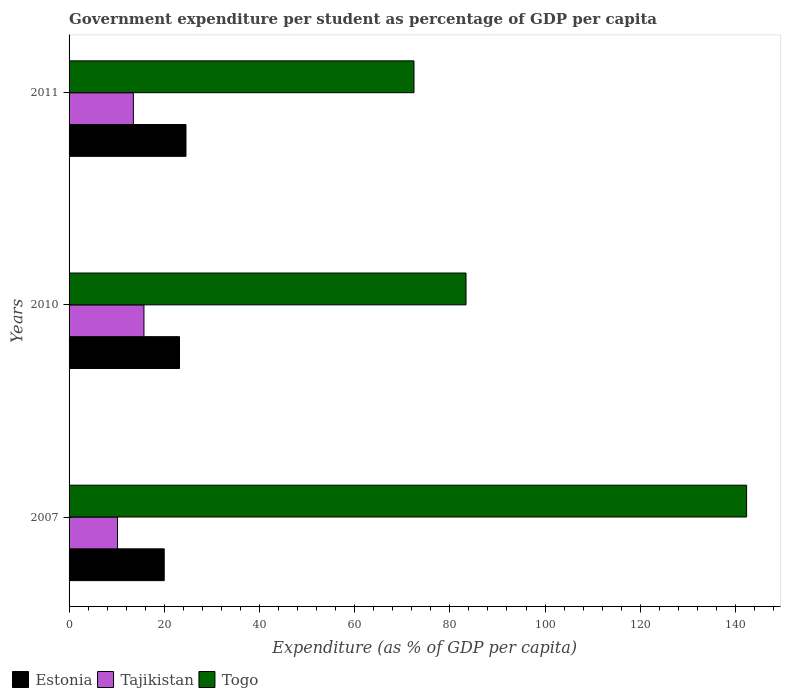How many different coloured bars are there?
Make the answer very short. 3. How many groups of bars are there?
Your answer should be compact. 3. Are the number of bars on each tick of the Y-axis equal?
Offer a very short reply. Yes. How many bars are there on the 1st tick from the bottom?
Make the answer very short. 3. What is the label of the 3rd group of bars from the top?
Keep it short and to the point. 2007. In how many cases, is the number of bars for a given year not equal to the number of legend labels?
Provide a succinct answer. 0. What is the percentage of expenditure per student in Tajikistan in 2007?
Provide a short and direct response. 10.18. Across all years, what is the maximum percentage of expenditure per student in Tajikistan?
Ensure brevity in your answer.  15.73. Across all years, what is the minimum percentage of expenditure per student in Tajikistan?
Keep it short and to the point. 10.18. In which year was the percentage of expenditure per student in Tajikistan minimum?
Ensure brevity in your answer.  2007. What is the total percentage of expenditure per student in Estonia in the graph?
Ensure brevity in your answer.  67.76. What is the difference between the percentage of expenditure per student in Togo in 2010 and that in 2011?
Keep it short and to the point. 10.93. What is the difference between the percentage of expenditure per student in Togo in 2010 and the percentage of expenditure per student in Estonia in 2011?
Your answer should be compact. 58.83. What is the average percentage of expenditure per student in Estonia per year?
Provide a succinct answer. 22.59. In the year 2010, what is the difference between the percentage of expenditure per student in Togo and percentage of expenditure per student in Estonia?
Your answer should be very brief. 60.19. In how many years, is the percentage of expenditure per student in Togo greater than 88 %?
Your response must be concise. 1. What is the ratio of the percentage of expenditure per student in Tajikistan in 2007 to that in 2011?
Your answer should be very brief. 0.75. Is the difference between the percentage of expenditure per student in Togo in 2007 and 2010 greater than the difference between the percentage of expenditure per student in Estonia in 2007 and 2010?
Your response must be concise. Yes. What is the difference between the highest and the second highest percentage of expenditure per student in Tajikistan?
Make the answer very short. 2.23. What is the difference between the highest and the lowest percentage of expenditure per student in Estonia?
Your answer should be very brief. 4.57. Is the sum of the percentage of expenditure per student in Togo in 2007 and 2011 greater than the maximum percentage of expenditure per student in Tajikistan across all years?
Ensure brevity in your answer.  Yes. What does the 1st bar from the top in 2010 represents?
Provide a succinct answer. Togo. What does the 1st bar from the bottom in 2010 represents?
Your response must be concise. Estonia. Is it the case that in every year, the sum of the percentage of expenditure per student in Estonia and percentage of expenditure per student in Togo is greater than the percentage of expenditure per student in Tajikistan?
Offer a very short reply. Yes. How many bars are there?
Ensure brevity in your answer.  9. How many years are there in the graph?
Offer a terse response. 3. Are the values on the major ticks of X-axis written in scientific E-notation?
Provide a short and direct response. No. Where does the legend appear in the graph?
Make the answer very short. Bottom left. What is the title of the graph?
Make the answer very short. Government expenditure per student as percentage of GDP per capita. What is the label or title of the X-axis?
Your response must be concise. Expenditure (as % of GDP per capita). What is the label or title of the Y-axis?
Your answer should be compact. Years. What is the Expenditure (as % of GDP per capita) in Estonia in 2007?
Give a very brief answer. 19.99. What is the Expenditure (as % of GDP per capita) in Tajikistan in 2007?
Give a very brief answer. 10.18. What is the Expenditure (as % of GDP per capita) in Togo in 2007?
Your answer should be very brief. 142.35. What is the Expenditure (as % of GDP per capita) of Estonia in 2010?
Keep it short and to the point. 23.2. What is the Expenditure (as % of GDP per capita) in Tajikistan in 2010?
Provide a succinct answer. 15.73. What is the Expenditure (as % of GDP per capita) of Togo in 2010?
Your response must be concise. 83.4. What is the Expenditure (as % of GDP per capita) of Estonia in 2011?
Ensure brevity in your answer.  24.56. What is the Expenditure (as % of GDP per capita) of Tajikistan in 2011?
Give a very brief answer. 13.51. What is the Expenditure (as % of GDP per capita) of Togo in 2011?
Provide a short and direct response. 72.47. Across all years, what is the maximum Expenditure (as % of GDP per capita) of Estonia?
Give a very brief answer. 24.56. Across all years, what is the maximum Expenditure (as % of GDP per capita) in Tajikistan?
Your answer should be very brief. 15.73. Across all years, what is the maximum Expenditure (as % of GDP per capita) in Togo?
Your answer should be compact. 142.35. Across all years, what is the minimum Expenditure (as % of GDP per capita) in Estonia?
Ensure brevity in your answer.  19.99. Across all years, what is the minimum Expenditure (as % of GDP per capita) in Tajikistan?
Your answer should be very brief. 10.18. Across all years, what is the minimum Expenditure (as % of GDP per capita) of Togo?
Provide a succinct answer. 72.47. What is the total Expenditure (as % of GDP per capita) in Estonia in the graph?
Keep it short and to the point. 67.76. What is the total Expenditure (as % of GDP per capita) in Tajikistan in the graph?
Provide a short and direct response. 39.42. What is the total Expenditure (as % of GDP per capita) of Togo in the graph?
Your answer should be compact. 298.21. What is the difference between the Expenditure (as % of GDP per capita) in Estonia in 2007 and that in 2010?
Give a very brief answer. -3.21. What is the difference between the Expenditure (as % of GDP per capita) of Tajikistan in 2007 and that in 2010?
Make the answer very short. -5.56. What is the difference between the Expenditure (as % of GDP per capita) of Togo in 2007 and that in 2010?
Keep it short and to the point. 58.95. What is the difference between the Expenditure (as % of GDP per capita) of Estonia in 2007 and that in 2011?
Provide a short and direct response. -4.57. What is the difference between the Expenditure (as % of GDP per capita) in Tajikistan in 2007 and that in 2011?
Provide a succinct answer. -3.33. What is the difference between the Expenditure (as % of GDP per capita) in Togo in 2007 and that in 2011?
Provide a succinct answer. 69.88. What is the difference between the Expenditure (as % of GDP per capita) of Estonia in 2010 and that in 2011?
Your answer should be very brief. -1.36. What is the difference between the Expenditure (as % of GDP per capita) in Tajikistan in 2010 and that in 2011?
Offer a terse response. 2.23. What is the difference between the Expenditure (as % of GDP per capita) in Togo in 2010 and that in 2011?
Keep it short and to the point. 10.93. What is the difference between the Expenditure (as % of GDP per capita) in Estonia in 2007 and the Expenditure (as % of GDP per capita) in Tajikistan in 2010?
Your response must be concise. 4.26. What is the difference between the Expenditure (as % of GDP per capita) in Estonia in 2007 and the Expenditure (as % of GDP per capita) in Togo in 2010?
Ensure brevity in your answer.  -63.41. What is the difference between the Expenditure (as % of GDP per capita) in Tajikistan in 2007 and the Expenditure (as % of GDP per capita) in Togo in 2010?
Provide a succinct answer. -73.22. What is the difference between the Expenditure (as % of GDP per capita) of Estonia in 2007 and the Expenditure (as % of GDP per capita) of Tajikistan in 2011?
Provide a short and direct response. 6.48. What is the difference between the Expenditure (as % of GDP per capita) of Estonia in 2007 and the Expenditure (as % of GDP per capita) of Togo in 2011?
Your response must be concise. -52.48. What is the difference between the Expenditure (as % of GDP per capita) in Tajikistan in 2007 and the Expenditure (as % of GDP per capita) in Togo in 2011?
Make the answer very short. -62.29. What is the difference between the Expenditure (as % of GDP per capita) of Estonia in 2010 and the Expenditure (as % of GDP per capita) of Tajikistan in 2011?
Make the answer very short. 9.7. What is the difference between the Expenditure (as % of GDP per capita) of Estonia in 2010 and the Expenditure (as % of GDP per capita) of Togo in 2011?
Give a very brief answer. -49.26. What is the difference between the Expenditure (as % of GDP per capita) in Tajikistan in 2010 and the Expenditure (as % of GDP per capita) in Togo in 2011?
Your response must be concise. -56.73. What is the average Expenditure (as % of GDP per capita) of Estonia per year?
Your answer should be very brief. 22.59. What is the average Expenditure (as % of GDP per capita) of Tajikistan per year?
Keep it short and to the point. 13.14. What is the average Expenditure (as % of GDP per capita) in Togo per year?
Your response must be concise. 99.41. In the year 2007, what is the difference between the Expenditure (as % of GDP per capita) in Estonia and Expenditure (as % of GDP per capita) in Tajikistan?
Your response must be concise. 9.81. In the year 2007, what is the difference between the Expenditure (as % of GDP per capita) of Estonia and Expenditure (as % of GDP per capita) of Togo?
Keep it short and to the point. -122.36. In the year 2007, what is the difference between the Expenditure (as % of GDP per capita) in Tajikistan and Expenditure (as % of GDP per capita) in Togo?
Your answer should be compact. -132.17. In the year 2010, what is the difference between the Expenditure (as % of GDP per capita) of Estonia and Expenditure (as % of GDP per capita) of Tajikistan?
Your answer should be compact. 7.47. In the year 2010, what is the difference between the Expenditure (as % of GDP per capita) in Estonia and Expenditure (as % of GDP per capita) in Togo?
Provide a short and direct response. -60.19. In the year 2010, what is the difference between the Expenditure (as % of GDP per capita) of Tajikistan and Expenditure (as % of GDP per capita) of Togo?
Offer a very short reply. -67.66. In the year 2011, what is the difference between the Expenditure (as % of GDP per capita) of Estonia and Expenditure (as % of GDP per capita) of Tajikistan?
Your answer should be compact. 11.06. In the year 2011, what is the difference between the Expenditure (as % of GDP per capita) of Estonia and Expenditure (as % of GDP per capita) of Togo?
Offer a terse response. -47.9. In the year 2011, what is the difference between the Expenditure (as % of GDP per capita) of Tajikistan and Expenditure (as % of GDP per capita) of Togo?
Provide a short and direct response. -58.96. What is the ratio of the Expenditure (as % of GDP per capita) in Estonia in 2007 to that in 2010?
Make the answer very short. 0.86. What is the ratio of the Expenditure (as % of GDP per capita) of Tajikistan in 2007 to that in 2010?
Your response must be concise. 0.65. What is the ratio of the Expenditure (as % of GDP per capita) of Togo in 2007 to that in 2010?
Keep it short and to the point. 1.71. What is the ratio of the Expenditure (as % of GDP per capita) of Estonia in 2007 to that in 2011?
Your answer should be very brief. 0.81. What is the ratio of the Expenditure (as % of GDP per capita) of Tajikistan in 2007 to that in 2011?
Provide a succinct answer. 0.75. What is the ratio of the Expenditure (as % of GDP per capita) in Togo in 2007 to that in 2011?
Offer a terse response. 1.96. What is the ratio of the Expenditure (as % of GDP per capita) of Estonia in 2010 to that in 2011?
Your answer should be very brief. 0.94. What is the ratio of the Expenditure (as % of GDP per capita) of Tajikistan in 2010 to that in 2011?
Your response must be concise. 1.16. What is the ratio of the Expenditure (as % of GDP per capita) in Togo in 2010 to that in 2011?
Offer a very short reply. 1.15. What is the difference between the highest and the second highest Expenditure (as % of GDP per capita) of Estonia?
Your answer should be very brief. 1.36. What is the difference between the highest and the second highest Expenditure (as % of GDP per capita) in Tajikistan?
Offer a very short reply. 2.23. What is the difference between the highest and the second highest Expenditure (as % of GDP per capita) of Togo?
Make the answer very short. 58.95. What is the difference between the highest and the lowest Expenditure (as % of GDP per capita) in Estonia?
Provide a succinct answer. 4.57. What is the difference between the highest and the lowest Expenditure (as % of GDP per capita) in Tajikistan?
Provide a succinct answer. 5.56. What is the difference between the highest and the lowest Expenditure (as % of GDP per capita) in Togo?
Your response must be concise. 69.88. 